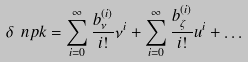<formula> <loc_0><loc_0><loc_500><loc_500>\delta \ n p k = \sum _ { i = 0 } ^ { \infty } \frac { b _ { \nu } ^ { ( i ) } } { i ! } \nu ^ { i } + \sum _ { i = 0 } ^ { \infty } \frac { b _ { \zeta } ^ { ( i ) } } { i ! } u ^ { i } + \dots</formula> 